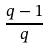Convert formula to latex. <formula><loc_0><loc_0><loc_500><loc_500>\frac { q - 1 } { q }</formula> 